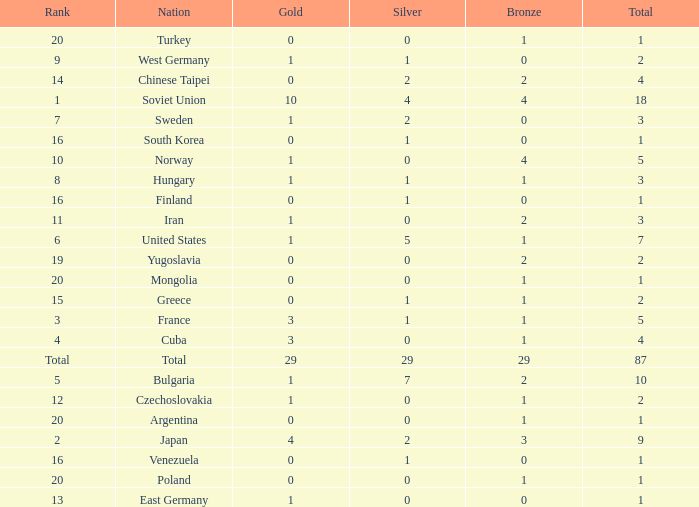What is the average number of bronze medals for total of all nations? 29.0. 